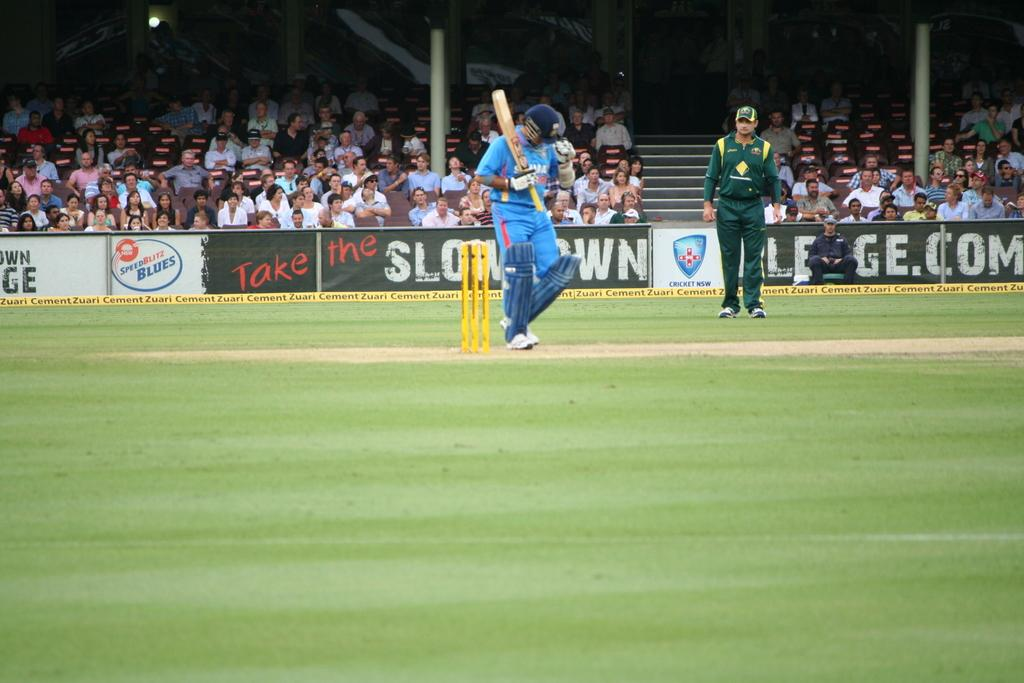<image>
Offer a succinct explanation of the picture presented. An out door sporting event being played in front of a Speed Blitz sign. 